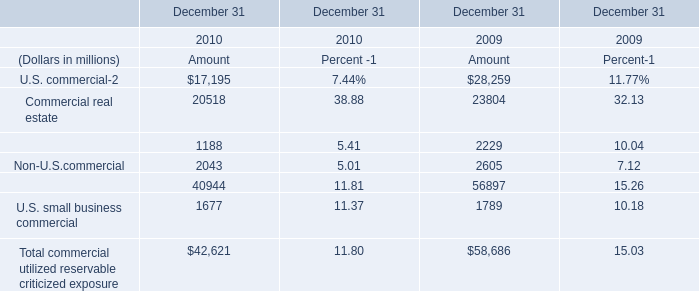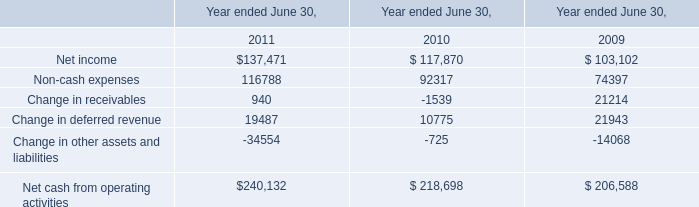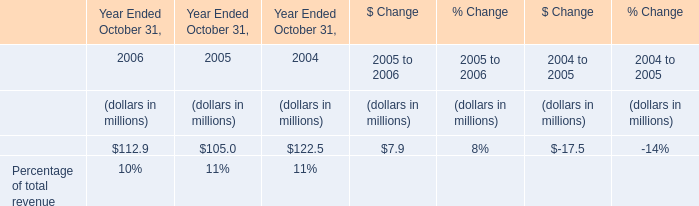What's the average of U.S. commercial of December 31 2010 Amount, and Net income of Year ended June 30, 2011 ? 
Computations: ((17195.0 + 137471.0) / 2)
Answer: 77333.0. 